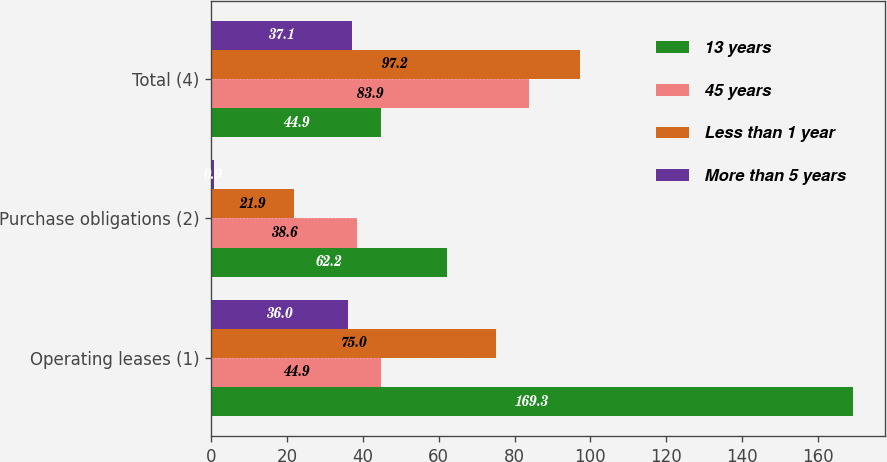Convert chart. <chart><loc_0><loc_0><loc_500><loc_500><stacked_bar_chart><ecel><fcel>Operating leases (1)<fcel>Purchase obligations (2)<fcel>Total (4)<nl><fcel>13 years<fcel>169.3<fcel>62.2<fcel>44.9<nl><fcel>45 years<fcel>44.9<fcel>38.6<fcel>83.9<nl><fcel>Less than 1 year<fcel>75<fcel>21.9<fcel>97.2<nl><fcel>More than 5 years<fcel>36<fcel>0.9<fcel>37.1<nl></chart> 